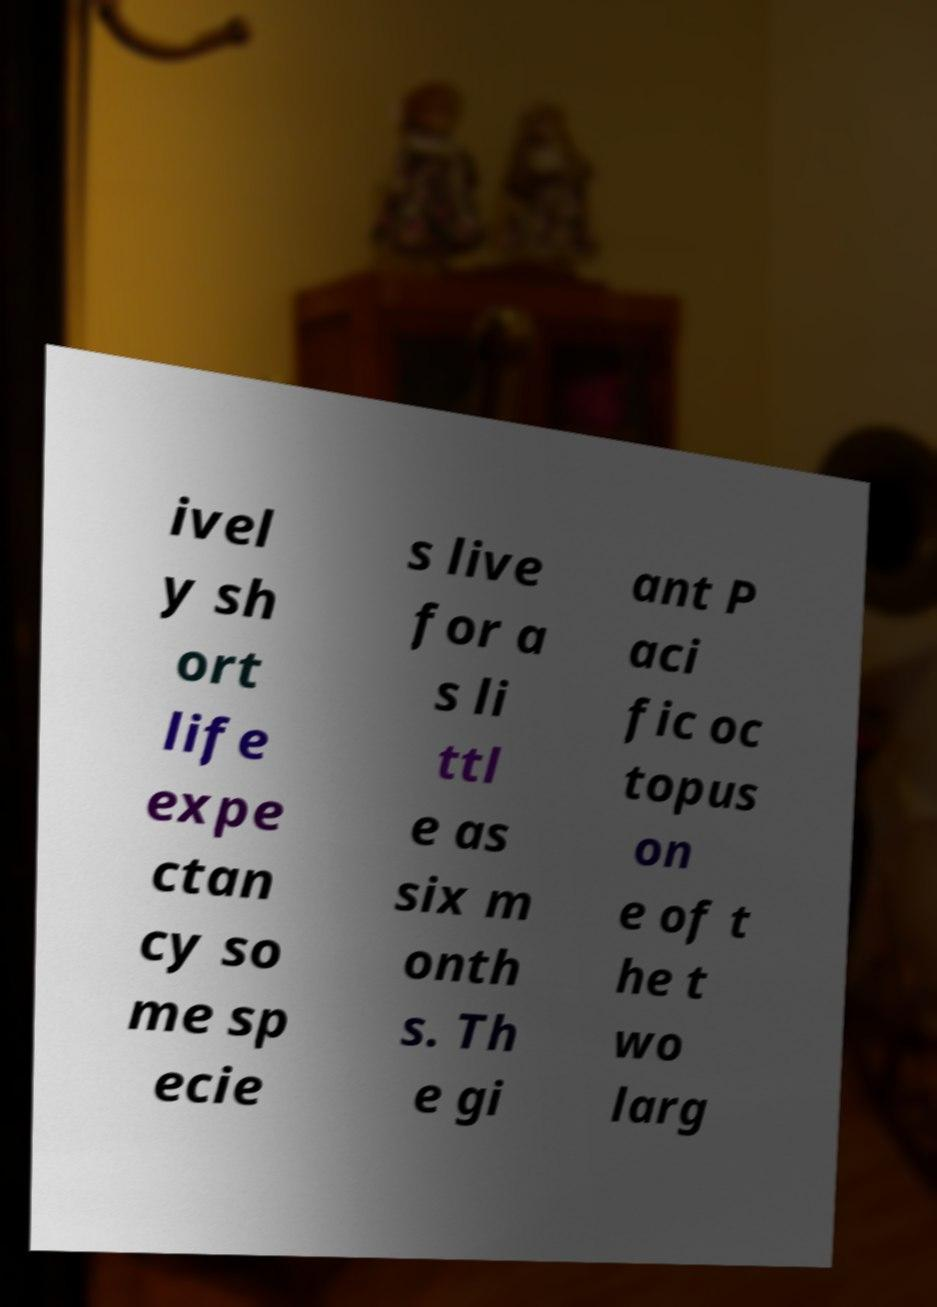Can you read and provide the text displayed in the image?This photo seems to have some interesting text. Can you extract and type it out for me? ivel y sh ort life expe ctan cy so me sp ecie s live for a s li ttl e as six m onth s. Th e gi ant P aci fic oc topus on e of t he t wo larg 